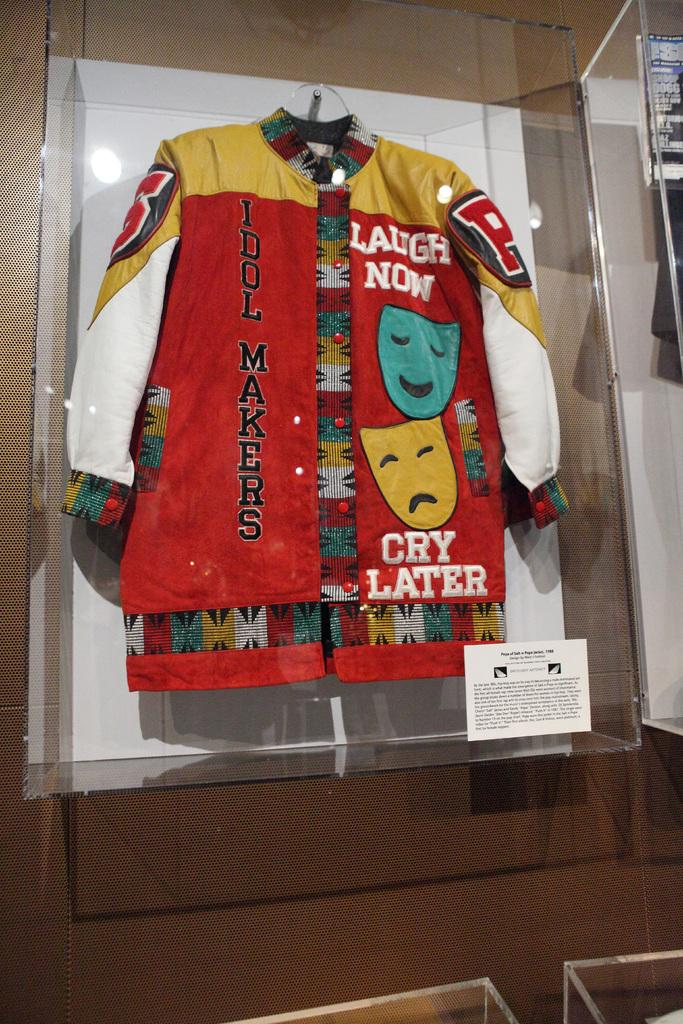<image>
Give a short and clear explanation of the subsequent image. a jacket that says cry later on it 